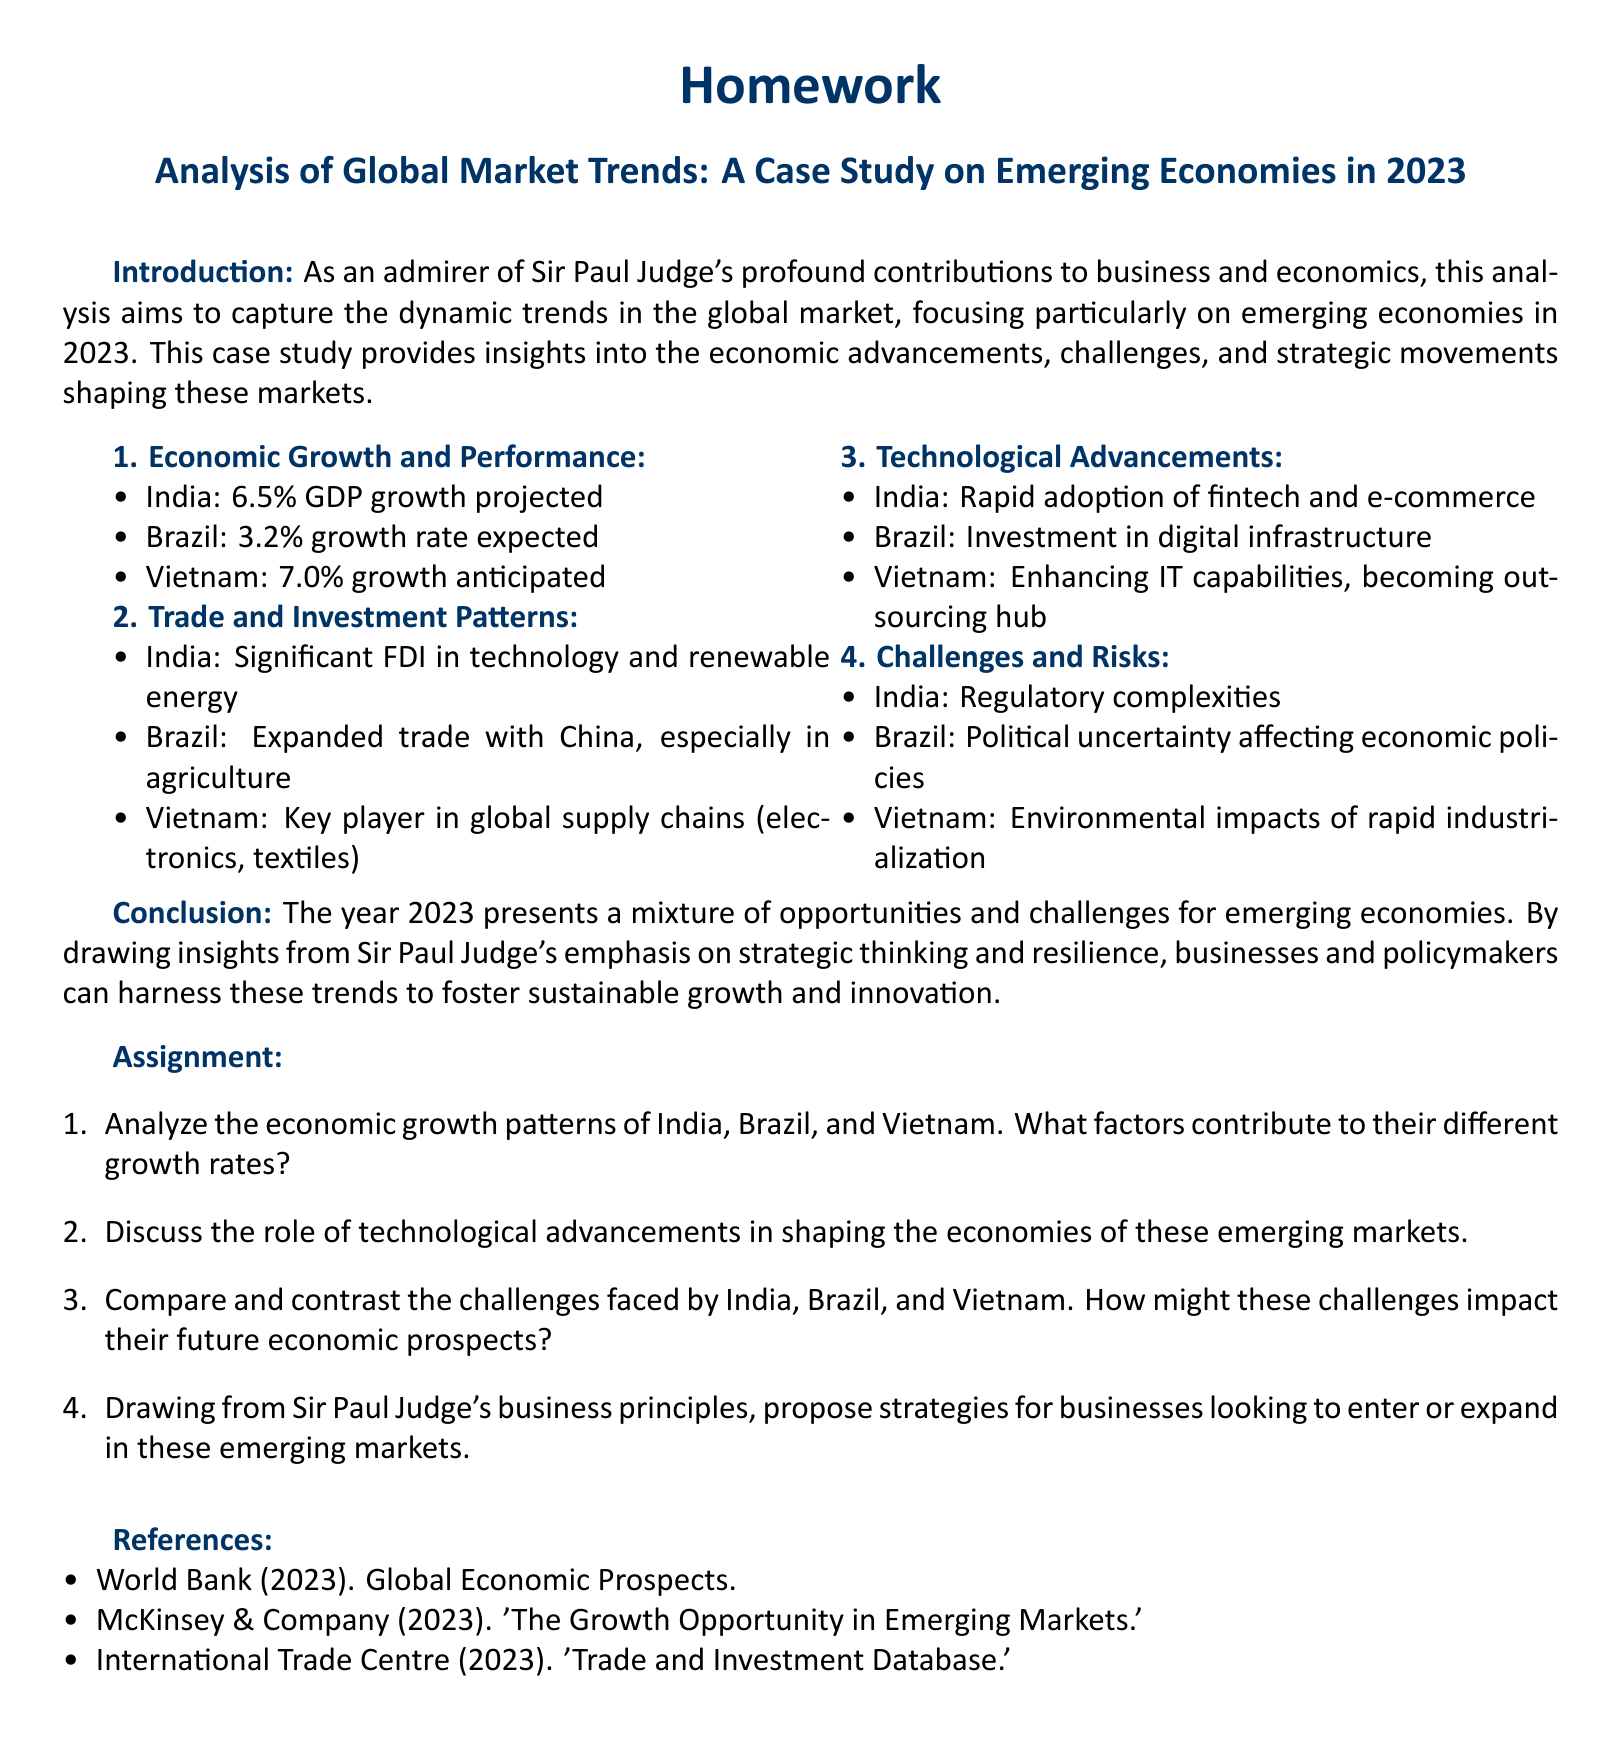What is the GDP growth rate projected for India in 2023? The document states that the GDP growth rate projected for India in 2023 is 6.5%.
Answer: 6.5% What significant investment areas are noted for India? The document mentions significant FDI in technology and renewable energy as key investment areas for India.
Answer: Technology and renewable energy Which country anticipates a 7.0% growth in 2023? According to the document, Vietnam anticipates a growth rate of 7.0% in 2023.
Answer: Vietnam What challenge is associated with Brazil's economic policies? The document highlights political uncertainty as a challenge affecting Brazil's economic policies.
Answer: Political uncertainty What technology is rapidly adopted in India? The document specifies the rapid adoption of fintech and e-commerce in India.
Answer: Fintech and e-commerce How is Vietnam characterized in relation to global supply chains? The document describes Vietnam as a key player in global supply chains, particularly in electronics and textiles.
Answer: Key player What overarching theme does the conclusion of the document emphasize? The conclusion emphasizes the mixture of opportunities and challenges for emerging economies in 2023.
Answer: Opportunities and challenges What specific organizational principle is referenced regarding business strategies? The document refers to Sir Paul Judge's emphasis on strategic thinking and resilience in relation to business strategies.
Answer: Strategic thinking and resilience What type of document is this considered? The structure and content of this document indicate that it is an academic homework assignment.
Answer: Homework assignment 